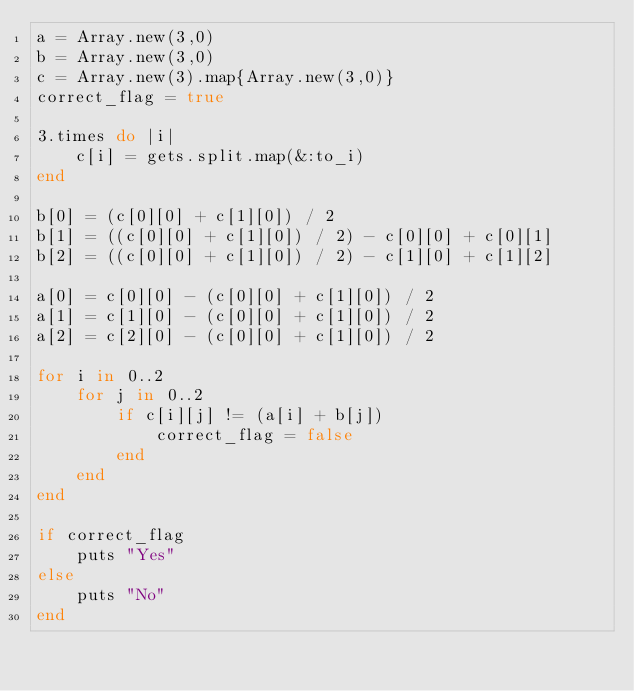Convert code to text. <code><loc_0><loc_0><loc_500><loc_500><_Ruby_>a = Array.new(3,0)
b = Array.new(3,0)
c = Array.new(3).map{Array.new(3,0)}
correct_flag = true

3.times do |i|
    c[i] = gets.split.map(&:to_i)
end

b[0] = (c[0][0] + c[1][0]) / 2
b[1] = ((c[0][0] + c[1][0]) / 2) - c[0][0] + c[0][1]
b[2] = ((c[0][0] + c[1][0]) / 2) - c[1][0] + c[1][2]

a[0] = c[0][0] - (c[0][0] + c[1][0]) / 2
a[1] = c[1][0] - (c[0][0] + c[1][0]) / 2
a[2] = c[2][0] - (c[0][0] + c[1][0]) / 2

for i in 0..2
    for j in 0..2
        if c[i][j] != (a[i] + b[j])
            correct_flag = false
        end
    end
end

if correct_flag
    puts "Yes"
else
    puts "No"
end</code> 